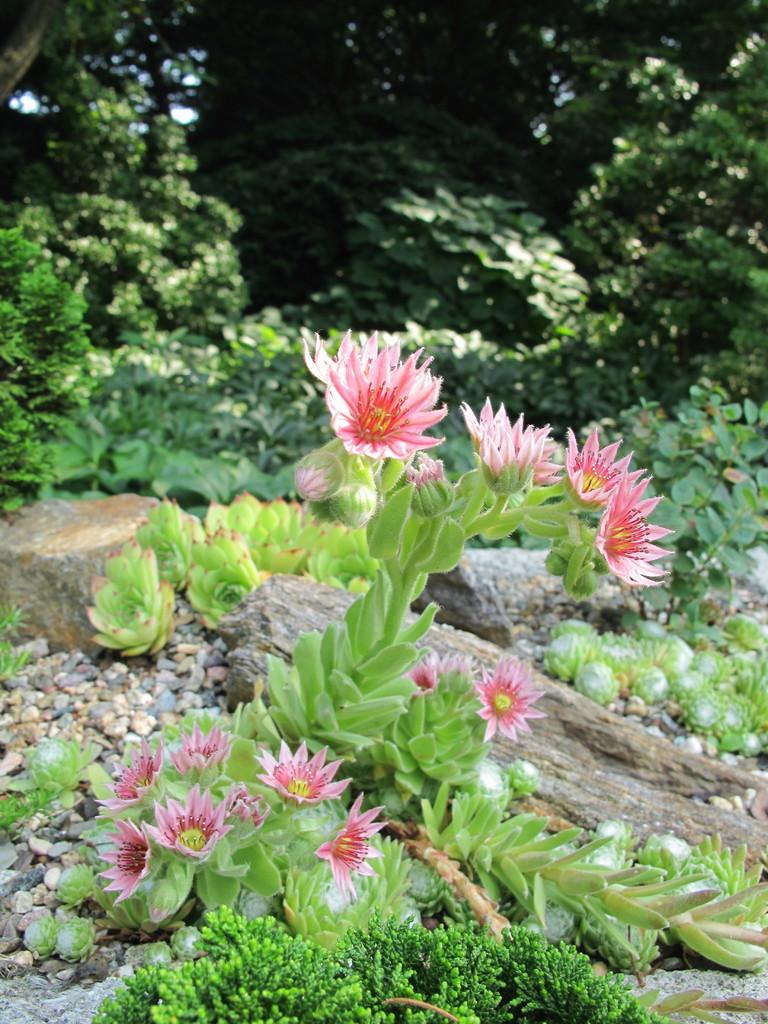What type of living organisms can be seen in the image? Flowers, plants, and trees are visible in the image. What else can be found in the image besides living organisms? There are stones in the image. Can you describe the natural environment depicted in the image? The image features a variety of plants, trees, and stones, which suggests a natural setting. What type of juice is being sold at the market in the image? There is no market or juice present in the image; it features flowers, stones, plants, and trees. How many flowers of the same type can be seen in the image? The image does not specify the number or type of flowers, so it cannot be determined from the image. 